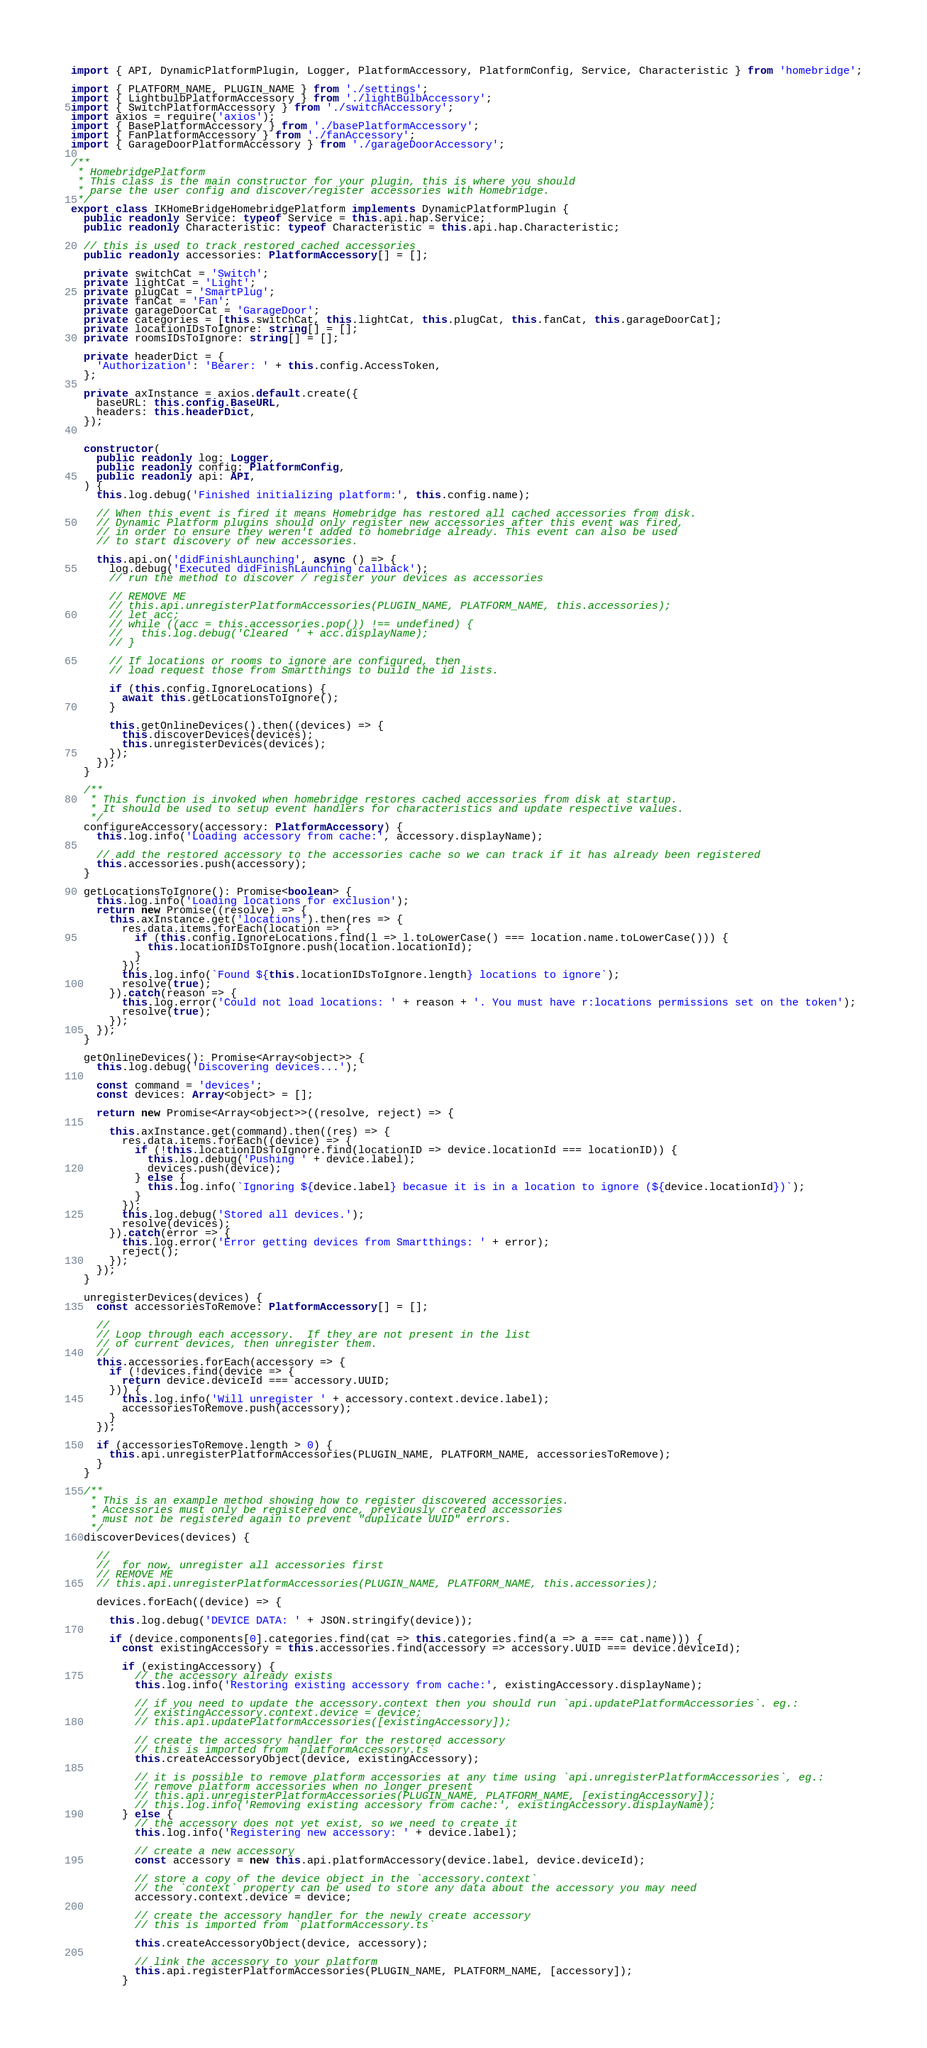Convert code to text. <code><loc_0><loc_0><loc_500><loc_500><_TypeScript_>import { API, DynamicPlatformPlugin, Logger, PlatformAccessory, PlatformConfig, Service, Characteristic } from 'homebridge';

import { PLATFORM_NAME, PLUGIN_NAME } from './settings';
import { LightbulbPlatformAccessory } from './lightBulbAccessory';
import { SwitchPlatformAccessory } from './switchAccessory';
import axios = require('axios');
import { BasePlatformAccessory } from './basePlatformAccessory';
import { FanPlatformAccessory } from './fanAccessory';
import { GarageDoorPlatformAccessory } from './garageDoorAccessory';

/**
 * HomebridgePlatform
 * This class is the main constructor for your plugin, this is where you should
 * parse the user config and discover/register accessories with Homebridge.
 */
export class IKHomeBridgeHomebridgePlatform implements DynamicPlatformPlugin {
  public readonly Service: typeof Service = this.api.hap.Service;
  public readonly Characteristic: typeof Characteristic = this.api.hap.Characteristic;

  // this is used to track restored cached accessories
  public readonly accessories: PlatformAccessory[] = [];

  private switchCat = 'Switch';
  private lightCat = 'Light';
  private plugCat = 'SmartPlug';
  private fanCat = 'Fan';
  private garageDoorCat = 'GarageDoor';
  private categories = [this.switchCat, this.lightCat, this.plugCat, this.fanCat, this.garageDoorCat];
  private locationIDsToIgnore: string[] = [];
  private roomsIDsToIgnore: string[] = [];

  private headerDict = {
    'Authorization': 'Bearer: ' + this.config.AccessToken,
  };

  private axInstance = axios.default.create({
    baseURL: this.config.BaseURL,
    headers: this.headerDict,
  });


  constructor(
    public readonly log: Logger,
    public readonly config: PlatformConfig,
    public readonly api: API,
  ) {
    this.log.debug('Finished initializing platform:', this.config.name);

    // When this event is fired it means Homebridge has restored all cached accessories from disk.
    // Dynamic Platform plugins should only register new accessories after this event was fired,
    // in order to ensure they weren't added to homebridge already. This event can also be used
    // to start discovery of new accessories.

    this.api.on('didFinishLaunching', async () => {
      log.debug('Executed didFinishLaunching callback');
      // run the method to discover / register your devices as accessories

      // REMOVE ME
      // this.api.unregisterPlatformAccessories(PLUGIN_NAME, PLATFORM_NAME, this.accessories);
      // let acc;
      // while ((acc = this.accessories.pop()) !== undefined) {
      //   this.log.debug('Cleared ' + acc.displayName);
      // }

      // If locations or rooms to ignore are configured, then
      // load request those from Smartthings to build the id lists.

      if (this.config.IgnoreLocations) {
        await this.getLocationsToIgnore();
      }

      this.getOnlineDevices().then((devices) => {
        this.discoverDevices(devices);
        this.unregisterDevices(devices);
      });
    });
  }

  /**
   * This function is invoked when homebridge restores cached accessories from disk at startup.
   * It should be used to setup event handlers for characteristics and update respective values.
   */
  configureAccessory(accessory: PlatformAccessory) {
    this.log.info('Loading accessory from cache:', accessory.displayName);

    // add the restored accessory to the accessories cache so we can track if it has already been registered
    this.accessories.push(accessory);
  }

  getLocationsToIgnore(): Promise<boolean> {
    this.log.info('Loading locations for exclusion');
    return new Promise((resolve) => {
      this.axInstance.get('locations').then(res => {
        res.data.items.forEach(location => {
          if (this.config.IgnoreLocations.find(l => l.toLowerCase() === location.name.toLowerCase())) {
            this.locationIDsToIgnore.push(location.locationId);
          }
        });
        this.log.info(`Found ${this.locationIDsToIgnore.length} locations to ignore`);
        resolve(true);
      }).catch(reason => {
        this.log.error('Could not load locations: ' + reason + '. You must have r:locations permissions set on the token');
        resolve(true);
      });
    });
  }

  getOnlineDevices(): Promise<Array<object>> {
    this.log.debug('Discovering devices...');

    const command = 'devices';
    const devices: Array<object> = [];

    return new Promise<Array<object>>((resolve, reject) => {

      this.axInstance.get(command).then((res) => {
        res.data.items.forEach((device) => {
          if (!this.locationIDsToIgnore.find(locationID => device.locationId === locationID)) {
            this.log.debug('Pushing ' + device.label);
            devices.push(device);
          } else {
            this.log.info(`Ignoring ${device.label} becasue it is in a location to ignore (${device.locationId})`);
          }
        });
        this.log.debug('Stored all devices.');
        resolve(devices);
      }).catch(error => {
        this.log.error('Error getting devices from Smartthings: ' + error);
        reject();
      });
    });
  }

  unregisterDevices(devices) {
    const accessoriesToRemove: PlatformAccessory[] = [];

    //
    // Loop through each accessory.  If they are not present in the list
    // of current devices, then unregister them.
    //
    this.accessories.forEach(accessory => {
      if (!devices.find(device => {
        return device.deviceId === accessory.UUID;
      })) {
        this.log.info('Will unregister ' + accessory.context.device.label);
        accessoriesToRemove.push(accessory);
      }
    });

    if (accessoriesToRemove.length > 0) {
      this.api.unregisterPlatformAccessories(PLUGIN_NAME, PLATFORM_NAME, accessoriesToRemove);
    }
  }

  /**
   * This is an example method showing how to register discovered accessories.
   * Accessories must only be registered once, previously created accessories
   * must not be registered again to prevent "duplicate UUID" errors.
   */
  discoverDevices(devices) {

    //
    //  for now, unregister all accessories first
    // REMOVE ME
    // this.api.unregisterPlatformAccessories(PLUGIN_NAME, PLATFORM_NAME, this.accessories);

    devices.forEach((device) => {

      this.log.debug('DEVICE DATA: ' + JSON.stringify(device));

      if (device.components[0].categories.find(cat => this.categories.find(a => a === cat.name))) {
        const existingAccessory = this.accessories.find(accessory => accessory.UUID === device.deviceId);

        if (existingAccessory) {
          // the accessory already exists
          this.log.info('Restoring existing accessory from cache:', existingAccessory.displayName);

          // if you need to update the accessory.context then you should run `api.updatePlatformAccessories`. eg.:
          // existingAccessory.context.device = device;
          // this.api.updatePlatformAccessories([existingAccessory]);

          // create the accessory handler for the restored accessory
          // this is imported from `platformAccessory.ts`
          this.createAccessoryObject(device, existingAccessory);

          // it is possible to remove platform accessories at any time using `api.unregisterPlatformAccessories`, eg.:
          // remove platform accessories when no longer present
          // this.api.unregisterPlatformAccessories(PLUGIN_NAME, PLATFORM_NAME, [existingAccessory]);
          // this.log.info('Removing existing accessory from cache:', existingAccessory.displayName);
        } else {
          // the accessory does not yet exist, so we need to create it
          this.log.info('Registering new accessory: ' + device.label);

          // create a new accessory
          const accessory = new this.api.platformAccessory(device.label, device.deviceId);

          // store a copy of the device object in the `accessory.context`
          // the `context` property can be used to store any data about the accessory you may need
          accessory.context.device = device;

          // create the accessory handler for the newly create accessory
          // this is imported from `platformAccessory.ts`

          this.createAccessoryObject(device, accessory);

          // link the accessory to your platform
          this.api.registerPlatformAccessories(PLUGIN_NAME, PLATFORM_NAME, [accessory]);
        }</code> 